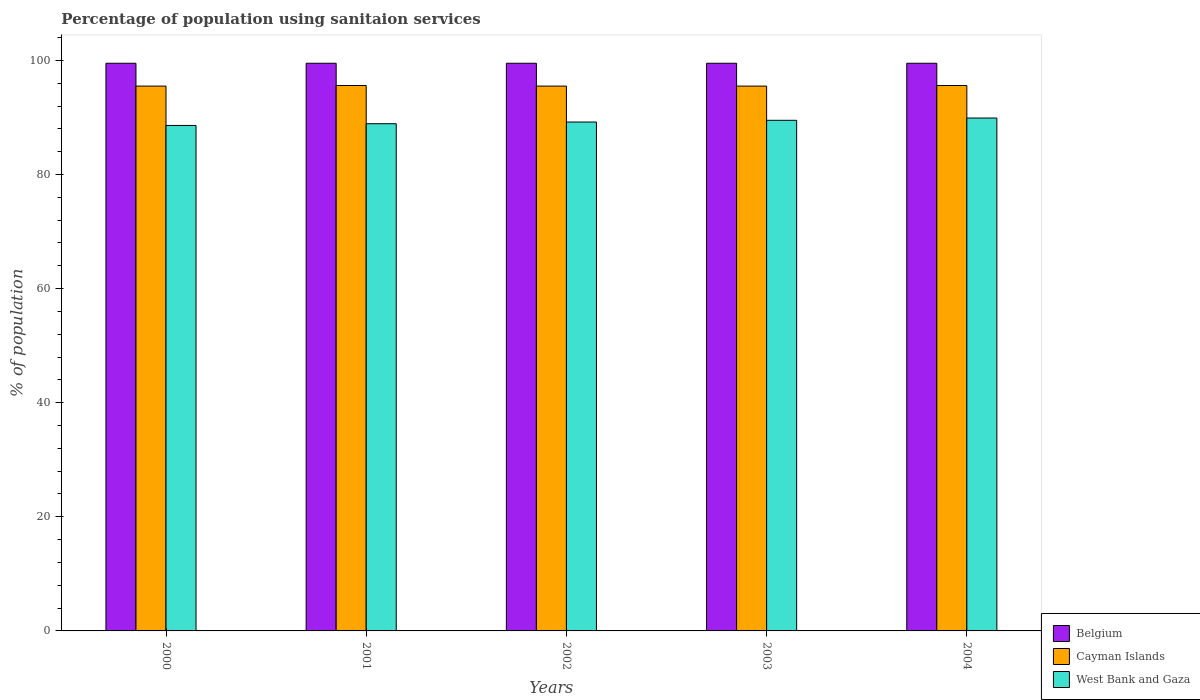How many groups of bars are there?
Offer a very short reply. 5. Are the number of bars per tick equal to the number of legend labels?
Give a very brief answer. Yes. How many bars are there on the 1st tick from the left?
Make the answer very short. 3. How many bars are there on the 4th tick from the right?
Make the answer very short. 3. What is the percentage of population using sanitaion services in Belgium in 2001?
Make the answer very short. 99.5. Across all years, what is the maximum percentage of population using sanitaion services in West Bank and Gaza?
Offer a terse response. 89.9. Across all years, what is the minimum percentage of population using sanitaion services in Belgium?
Keep it short and to the point. 99.5. In which year was the percentage of population using sanitaion services in Belgium maximum?
Your answer should be compact. 2000. In which year was the percentage of population using sanitaion services in Cayman Islands minimum?
Your response must be concise. 2000. What is the total percentage of population using sanitaion services in Belgium in the graph?
Provide a succinct answer. 497.5. What is the difference between the percentage of population using sanitaion services in Belgium in 2001 and the percentage of population using sanitaion services in Cayman Islands in 2004?
Provide a short and direct response. 3.9. What is the average percentage of population using sanitaion services in West Bank and Gaza per year?
Ensure brevity in your answer.  89.22. In the year 2004, what is the difference between the percentage of population using sanitaion services in Belgium and percentage of population using sanitaion services in West Bank and Gaza?
Provide a succinct answer. 9.6. In how many years, is the percentage of population using sanitaion services in Cayman Islands greater than 96 %?
Make the answer very short. 0. What is the ratio of the percentage of population using sanitaion services in Cayman Islands in 2001 to that in 2004?
Keep it short and to the point. 1. What is the difference between the highest and the lowest percentage of population using sanitaion services in West Bank and Gaza?
Your response must be concise. 1.3. Is the sum of the percentage of population using sanitaion services in Cayman Islands in 2000 and 2003 greater than the maximum percentage of population using sanitaion services in Belgium across all years?
Offer a terse response. Yes. What does the 2nd bar from the left in 2002 represents?
Your answer should be compact. Cayman Islands. What does the 1st bar from the right in 2001 represents?
Your answer should be very brief. West Bank and Gaza. Is it the case that in every year, the sum of the percentage of population using sanitaion services in Cayman Islands and percentage of population using sanitaion services in Belgium is greater than the percentage of population using sanitaion services in West Bank and Gaza?
Provide a succinct answer. Yes. How many bars are there?
Ensure brevity in your answer.  15. Are all the bars in the graph horizontal?
Provide a succinct answer. No. How many years are there in the graph?
Make the answer very short. 5. What is the difference between two consecutive major ticks on the Y-axis?
Your answer should be compact. 20. Are the values on the major ticks of Y-axis written in scientific E-notation?
Your answer should be compact. No. Does the graph contain grids?
Keep it short and to the point. No. Where does the legend appear in the graph?
Your answer should be very brief. Bottom right. What is the title of the graph?
Give a very brief answer. Percentage of population using sanitaion services. What is the label or title of the X-axis?
Your answer should be compact. Years. What is the label or title of the Y-axis?
Give a very brief answer. % of population. What is the % of population of Belgium in 2000?
Your answer should be compact. 99.5. What is the % of population in Cayman Islands in 2000?
Offer a terse response. 95.5. What is the % of population in West Bank and Gaza in 2000?
Offer a very short reply. 88.6. What is the % of population in Belgium in 2001?
Provide a short and direct response. 99.5. What is the % of population in Cayman Islands in 2001?
Give a very brief answer. 95.6. What is the % of population of West Bank and Gaza in 2001?
Ensure brevity in your answer.  88.9. What is the % of population of Belgium in 2002?
Provide a short and direct response. 99.5. What is the % of population of Cayman Islands in 2002?
Provide a succinct answer. 95.5. What is the % of population of West Bank and Gaza in 2002?
Provide a succinct answer. 89.2. What is the % of population in Belgium in 2003?
Your answer should be very brief. 99.5. What is the % of population in Cayman Islands in 2003?
Offer a terse response. 95.5. What is the % of population of West Bank and Gaza in 2003?
Keep it short and to the point. 89.5. What is the % of population of Belgium in 2004?
Provide a short and direct response. 99.5. What is the % of population in Cayman Islands in 2004?
Offer a very short reply. 95.6. What is the % of population in West Bank and Gaza in 2004?
Your answer should be very brief. 89.9. Across all years, what is the maximum % of population of Belgium?
Make the answer very short. 99.5. Across all years, what is the maximum % of population in Cayman Islands?
Offer a very short reply. 95.6. Across all years, what is the maximum % of population in West Bank and Gaza?
Provide a succinct answer. 89.9. Across all years, what is the minimum % of population in Belgium?
Offer a very short reply. 99.5. Across all years, what is the minimum % of population of Cayman Islands?
Make the answer very short. 95.5. Across all years, what is the minimum % of population in West Bank and Gaza?
Your response must be concise. 88.6. What is the total % of population in Belgium in the graph?
Your response must be concise. 497.5. What is the total % of population in Cayman Islands in the graph?
Offer a terse response. 477.7. What is the total % of population of West Bank and Gaza in the graph?
Provide a short and direct response. 446.1. What is the difference between the % of population in Belgium in 2000 and that in 2001?
Offer a very short reply. 0. What is the difference between the % of population of West Bank and Gaza in 2000 and that in 2001?
Offer a very short reply. -0.3. What is the difference between the % of population of Belgium in 2000 and that in 2003?
Ensure brevity in your answer.  0. What is the difference between the % of population in Belgium in 2001 and that in 2002?
Ensure brevity in your answer.  0. What is the difference between the % of population of Belgium in 2001 and that in 2003?
Give a very brief answer. 0. What is the difference between the % of population of Belgium in 2001 and that in 2004?
Provide a short and direct response. 0. What is the difference between the % of population in Belgium in 2002 and that in 2004?
Provide a short and direct response. 0. What is the difference between the % of population of Belgium in 2003 and that in 2004?
Ensure brevity in your answer.  0. What is the difference between the % of population in West Bank and Gaza in 2003 and that in 2004?
Keep it short and to the point. -0.4. What is the difference between the % of population in Belgium in 2000 and the % of population in West Bank and Gaza in 2001?
Your response must be concise. 10.6. What is the difference between the % of population of Cayman Islands in 2000 and the % of population of West Bank and Gaza in 2001?
Your answer should be very brief. 6.6. What is the difference between the % of population of Belgium in 2000 and the % of population of West Bank and Gaza in 2002?
Your response must be concise. 10.3. What is the difference between the % of population of Cayman Islands in 2000 and the % of population of West Bank and Gaza in 2002?
Offer a terse response. 6.3. What is the difference between the % of population of Belgium in 2000 and the % of population of Cayman Islands in 2003?
Give a very brief answer. 4. What is the difference between the % of population of Belgium in 2000 and the % of population of Cayman Islands in 2004?
Your response must be concise. 3.9. What is the difference between the % of population in Belgium in 2001 and the % of population in Cayman Islands in 2002?
Give a very brief answer. 4. What is the difference between the % of population in Belgium in 2001 and the % of population in West Bank and Gaza in 2002?
Provide a short and direct response. 10.3. What is the difference between the % of population of Cayman Islands in 2001 and the % of population of West Bank and Gaza in 2002?
Your answer should be compact. 6.4. What is the difference between the % of population of Belgium in 2001 and the % of population of West Bank and Gaza in 2003?
Give a very brief answer. 10. What is the difference between the % of population of Cayman Islands in 2001 and the % of population of West Bank and Gaza in 2003?
Offer a terse response. 6.1. What is the difference between the % of population of Belgium in 2001 and the % of population of Cayman Islands in 2004?
Offer a very short reply. 3.9. What is the difference between the % of population in Belgium in 2002 and the % of population in Cayman Islands in 2004?
Make the answer very short. 3.9. What is the difference between the % of population of Cayman Islands in 2002 and the % of population of West Bank and Gaza in 2004?
Offer a very short reply. 5.6. What is the difference between the % of population of Cayman Islands in 2003 and the % of population of West Bank and Gaza in 2004?
Your response must be concise. 5.6. What is the average % of population in Belgium per year?
Provide a short and direct response. 99.5. What is the average % of population of Cayman Islands per year?
Ensure brevity in your answer.  95.54. What is the average % of population in West Bank and Gaza per year?
Offer a very short reply. 89.22. In the year 2000, what is the difference between the % of population in Belgium and % of population in West Bank and Gaza?
Make the answer very short. 10.9. In the year 2000, what is the difference between the % of population in Cayman Islands and % of population in West Bank and Gaza?
Offer a very short reply. 6.9. In the year 2001, what is the difference between the % of population of Cayman Islands and % of population of West Bank and Gaza?
Your response must be concise. 6.7. In the year 2002, what is the difference between the % of population of Belgium and % of population of West Bank and Gaza?
Offer a terse response. 10.3. In the year 2003, what is the difference between the % of population in Belgium and % of population in Cayman Islands?
Ensure brevity in your answer.  4. In the year 2003, what is the difference between the % of population in Belgium and % of population in West Bank and Gaza?
Your answer should be compact. 10. In the year 2003, what is the difference between the % of population of Cayman Islands and % of population of West Bank and Gaza?
Provide a succinct answer. 6. In the year 2004, what is the difference between the % of population of Belgium and % of population of Cayman Islands?
Keep it short and to the point. 3.9. In the year 2004, what is the difference between the % of population of Cayman Islands and % of population of West Bank and Gaza?
Make the answer very short. 5.7. What is the ratio of the % of population of Belgium in 2000 to that in 2001?
Provide a succinct answer. 1. What is the ratio of the % of population in Cayman Islands in 2000 to that in 2001?
Give a very brief answer. 1. What is the ratio of the % of population in Belgium in 2000 to that in 2002?
Offer a very short reply. 1. What is the ratio of the % of population in Cayman Islands in 2000 to that in 2002?
Offer a terse response. 1. What is the ratio of the % of population in West Bank and Gaza in 2000 to that in 2002?
Give a very brief answer. 0.99. What is the ratio of the % of population in Belgium in 2000 to that in 2003?
Offer a terse response. 1. What is the ratio of the % of population in Cayman Islands in 2000 to that in 2003?
Give a very brief answer. 1. What is the ratio of the % of population of West Bank and Gaza in 2000 to that in 2003?
Provide a short and direct response. 0.99. What is the ratio of the % of population in Cayman Islands in 2000 to that in 2004?
Provide a short and direct response. 1. What is the ratio of the % of population in West Bank and Gaza in 2000 to that in 2004?
Your answer should be very brief. 0.99. What is the ratio of the % of population of Belgium in 2001 to that in 2002?
Give a very brief answer. 1. What is the ratio of the % of population in Cayman Islands in 2001 to that in 2002?
Your response must be concise. 1. What is the ratio of the % of population of West Bank and Gaza in 2001 to that in 2002?
Provide a succinct answer. 1. What is the ratio of the % of population in Cayman Islands in 2001 to that in 2003?
Your answer should be very brief. 1. What is the ratio of the % of population of Cayman Islands in 2001 to that in 2004?
Make the answer very short. 1. What is the ratio of the % of population in West Bank and Gaza in 2001 to that in 2004?
Offer a very short reply. 0.99. What is the ratio of the % of population in Cayman Islands in 2002 to that in 2004?
Make the answer very short. 1. What is the ratio of the % of population of West Bank and Gaza in 2002 to that in 2004?
Your answer should be very brief. 0.99. What is the ratio of the % of population in Cayman Islands in 2003 to that in 2004?
Provide a short and direct response. 1. What is the difference between the highest and the second highest % of population in Belgium?
Offer a terse response. 0. What is the difference between the highest and the lowest % of population of Belgium?
Ensure brevity in your answer.  0. What is the difference between the highest and the lowest % of population of Cayman Islands?
Your answer should be compact. 0.1. What is the difference between the highest and the lowest % of population in West Bank and Gaza?
Keep it short and to the point. 1.3. 